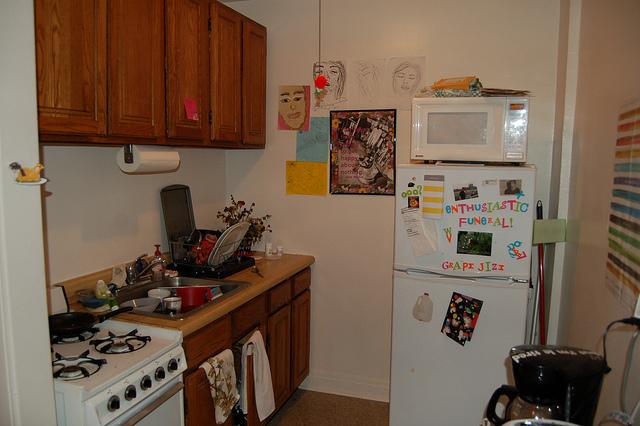What are on the freezer door?
Quick response, please. Magnets. Are there any bottles on top of the fridge?
Short answer required. No. Is the kitchen clean?
Quick response, please. No. What are the items lined up in the corner?
Answer briefly. Dishes. What things are on the refrigerator?
Quick response, please. Magnets. How many oven mitts are hanging on cupboards?
Quick response, please. 0. Where is the microwave?
Answer briefly. On fridge. What color is the frying pan?
Quick response, please. Black. Is the sink overflowing with dishes?
Be succinct. Yes. What do the magnets on the fridge spell out?
Quick response, please. Enthusiastic. Is anything being cooked on the stove?
Give a very brief answer. No. What is on top of the refrigerator?
Short answer required. Microwave. What is above the stove?
Give a very brief answer. Cabinets. Is this a modern kitchen?
Be succinct. No. How many bowls?
Be succinct. 2. Are the dishes clean or dirty?
Give a very brief answer. Dirty. What are the appliances made out of?
Concise answer only. Metal. What color is the microwave?
Write a very short answer. White. What room is this?
Keep it brief. Kitchen. How many chairs can be seen?
Short answer required. 0. Does the kitchen appear to be dirty and unkempt?
Concise answer only. Yes. What color is the cabinet?
Short answer required. Brown. What color is the countertop in the bottom photo?
Give a very brief answer. Brown. Is the stove a gas stove?
Be succinct. Yes. What is hanging above the microwave?
Short answer required. Picture. What type of drink ware is on top of the cabinet?
Write a very short answer. Cup. What color are the cabinets?
Give a very brief answer. Brown. What color are the salt and pepper shakers?
Quick response, please. White. What kind of room is this?
Quick response, please. Kitchen. What would the box on top of the refrigerator hold?
Concise answer only. Food. What room is this a picture of?
Quick response, please. Kitchen. What are the hand towels hanging in front of?
Be succinct. Cabinet. Is the sink clean?
Give a very brief answer. No. What happened to the cabinets doors?
Keep it brief. Nothing. 